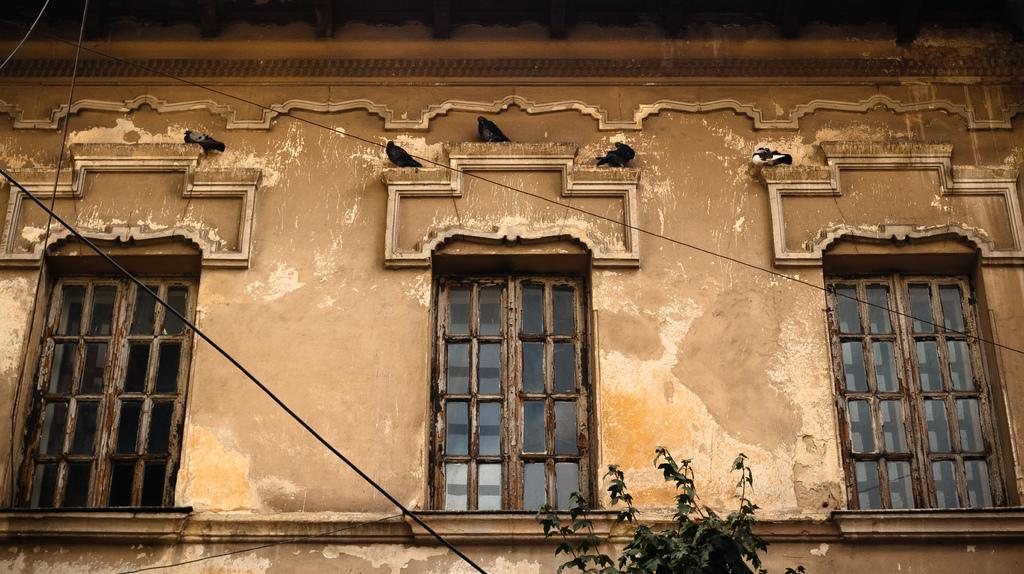What type of structure is present in the image? There is a building in the image. What feature can be seen on the building? The building has windows. What is located at the bottom of the image? There is a plant and a wire at the bottom of the image. What type of animals can be seen in the image? Birds are visible in the image. What is the son writing about in the garden in the image? There is no son or garden present in the image. 